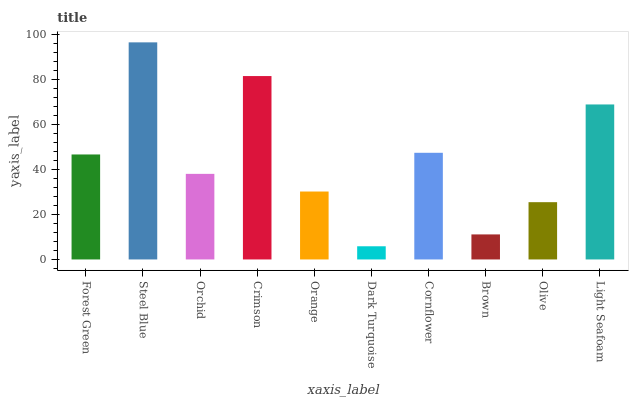Is Dark Turquoise the minimum?
Answer yes or no. Yes. Is Steel Blue the maximum?
Answer yes or no. Yes. Is Orchid the minimum?
Answer yes or no. No. Is Orchid the maximum?
Answer yes or no. No. Is Steel Blue greater than Orchid?
Answer yes or no. Yes. Is Orchid less than Steel Blue?
Answer yes or no. Yes. Is Orchid greater than Steel Blue?
Answer yes or no. No. Is Steel Blue less than Orchid?
Answer yes or no. No. Is Forest Green the high median?
Answer yes or no. Yes. Is Orchid the low median?
Answer yes or no. Yes. Is Orchid the high median?
Answer yes or no. No. Is Brown the low median?
Answer yes or no. No. 